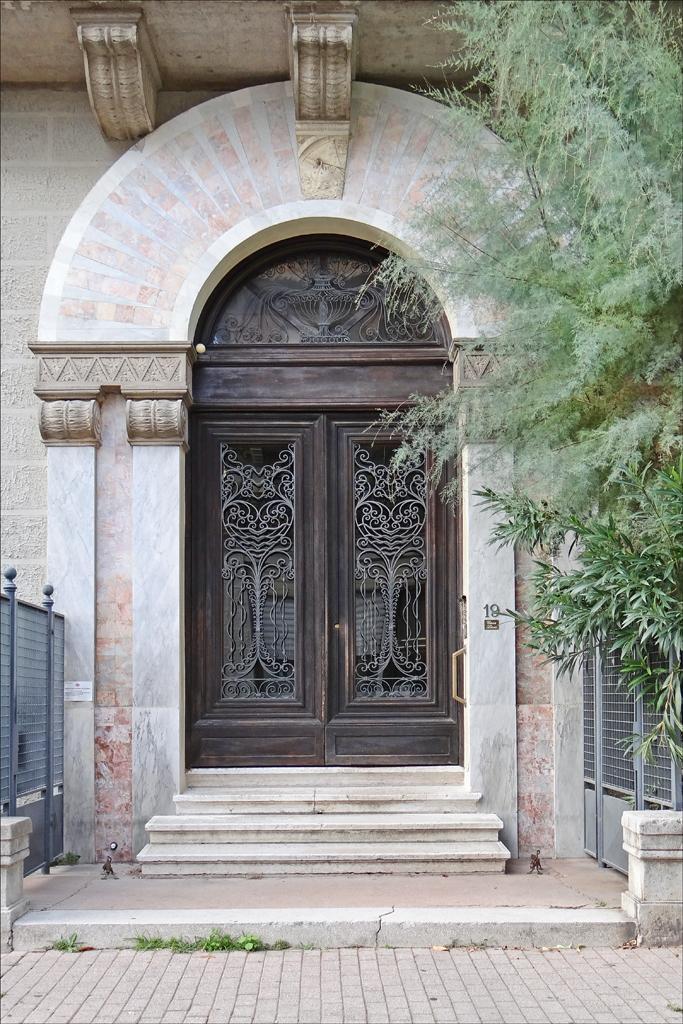In one or two sentences, can you explain what this image depicts? In the center of the image there is a door and stairs. On the right side of the image we can see tree and fencing. On the left side of the image there is fencing. At the bottom we can see ground. 